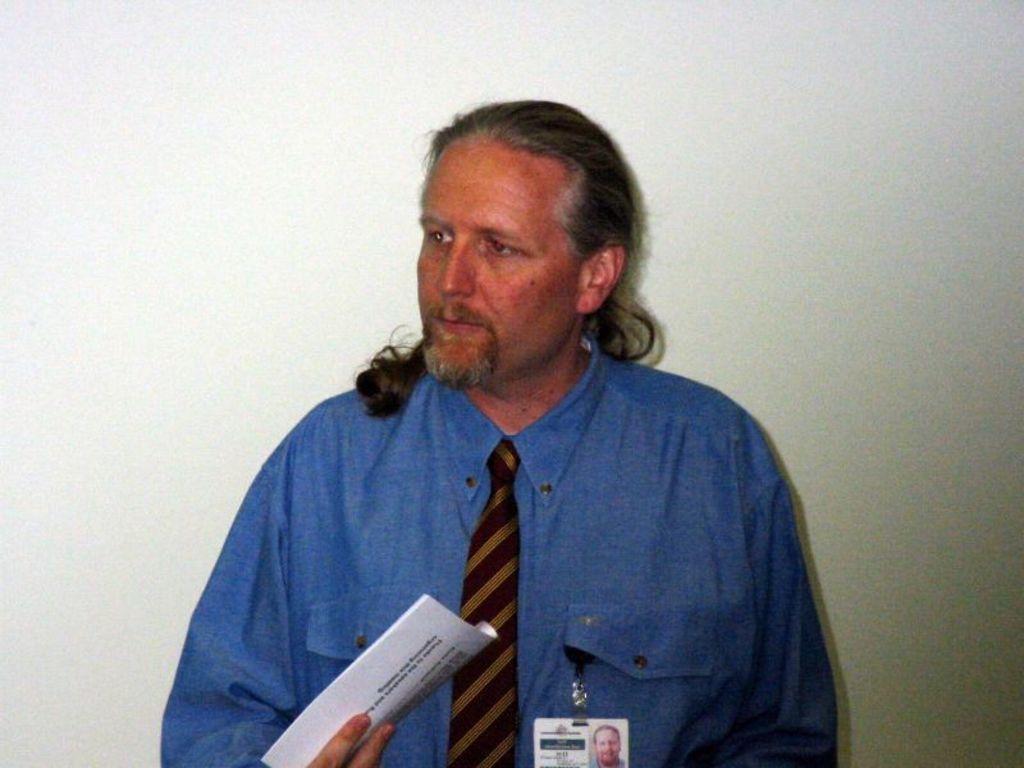What is the person in the image doing? The person is holding papers in the image. What is the person wearing on their upper body? The person is wearing a blue shirt and a brown color tie. What color is the background of the image? The background of the image is white. What type of bead is used to create the texture of the person's shirt in the image? There is no mention of beads or texture in the description of the person's shirt, which is simply described as blue. 